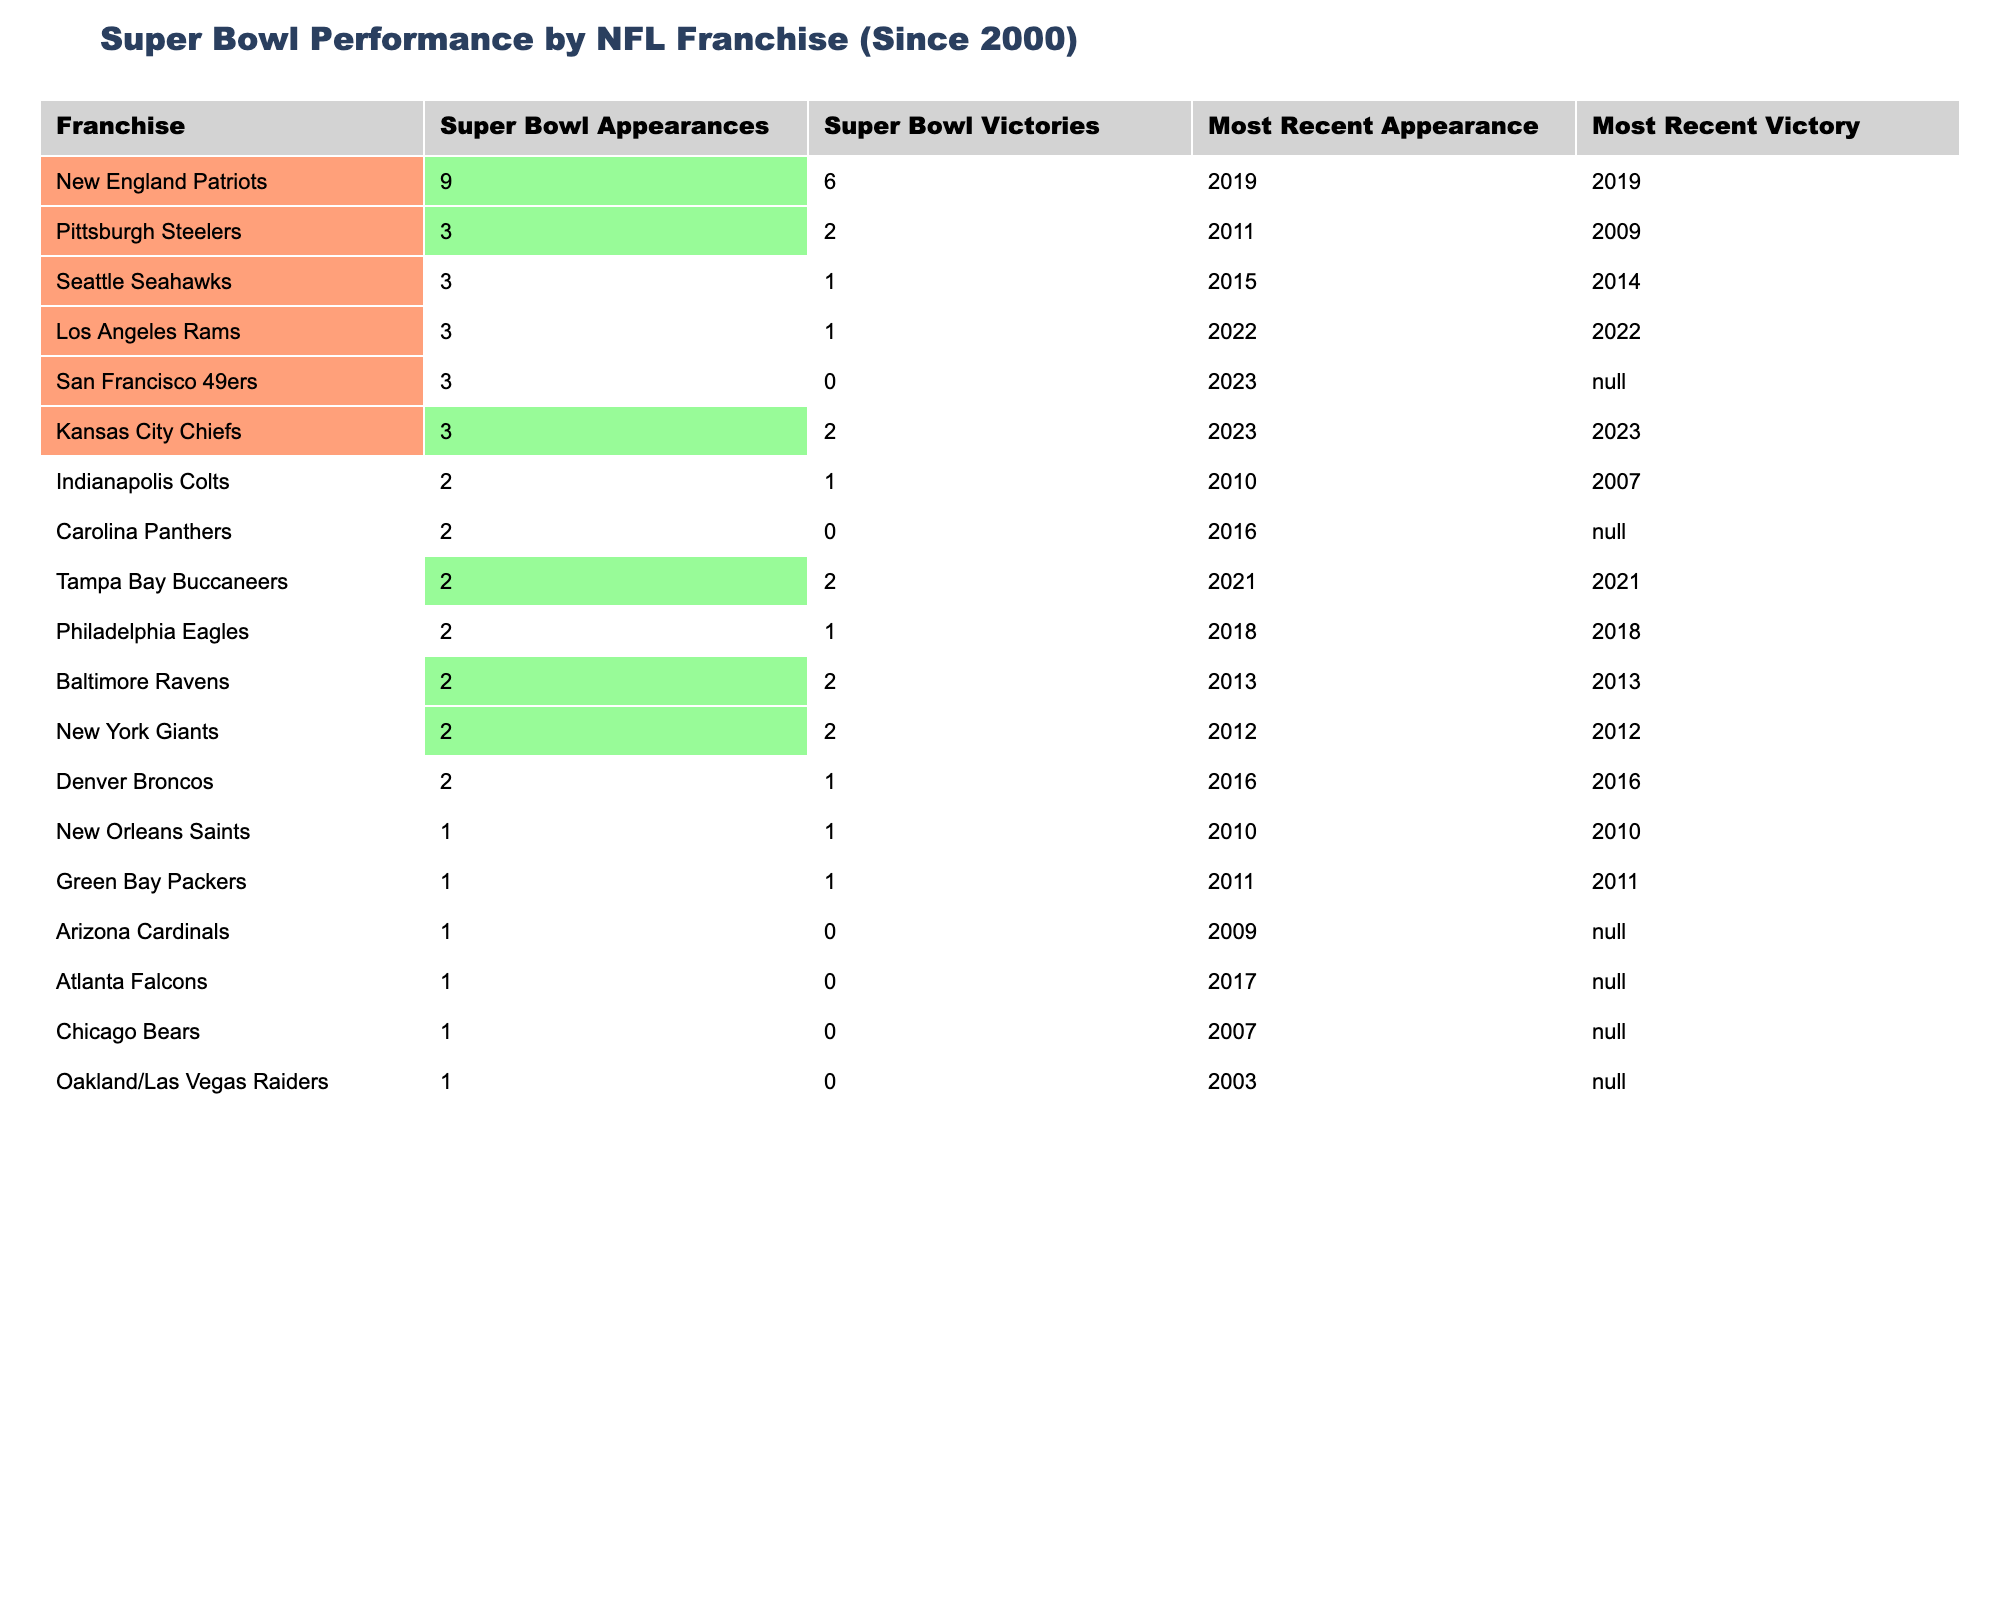What franchise has the most Super Bowl appearances since 2000? The data shows that the New England Patriots have the highest number of Super Bowl appearances with a total of 9.
Answer: New England Patriots Which franchises have won more than one Super Bowl since 2000? The table indicates that the New England Patriots, Pittsburgh Steelers, and Kansas City Chiefs have more than one Super Bowl victory, as they list 6, 2, and 2 victories respectively.
Answer: New England Patriots, Pittsburgh Steelers, Kansas City Chiefs How many franchises had no Super Bowl victories since 2000? From the table, the franchises that have not won a Super Bowl are the San Francisco 49ers, Carolina Panthers, Arizona Cardinals, Atlanta Falcons, Chicago Bears, and Oakland/Las Vegas Raiders, totaling 6 franchises.
Answer: 6 Which franchise had its most recent Super Bowl victory in 2007? The Indianapolis Colts had their most recent victory in 2007, as stated in the table.
Answer: Indianapolis Colts What is the difference in Super Bowl victories between the New England Patriots and the Seattle Seahawks? The New England Patriots have 6 Super Bowl victories, while the Seattle Seahawks have 1. The difference is calculated as 6 - 1 = 5.
Answer: 5 Which franchise has the most recent Super Bowl appearance? The Kansas City Chiefs had their most recent Super Bowl appearance in 2023, which is the latest listed in the table.
Answer: Kansas City Chiefs Have the New York Giants had more Super Bowl victories than the Denver Broncos since 2000? Yes, the New York Giants have 2 victories while the Denver Broncos have 1 victory since 2000, according to the table.
Answer: Yes What is the average number of Super Bowl victories among franchises with 2 or more appearances? The franchises with 2 or more appearances are the New England Patriots (6), Pittsburgh Steelers (2), Seattle Seahawks (1), Kansas City Chiefs (2), and Tampa Bay Buccaneers (2), making a total of 13 victories; the average is 13 divided by 6, which equals approximately 2.17.
Answer: Approximately 2.17 